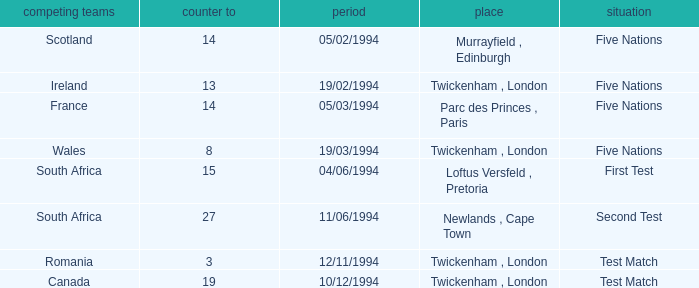How many against have a status of first test? 1.0. 